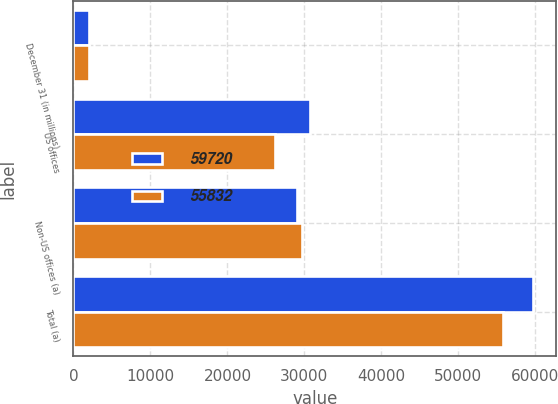Convert chart to OTSL. <chart><loc_0><loc_0><loc_500><loc_500><stacked_bar_chart><ecel><fcel>December 31 (in millions)<fcel>US offices<fcel>Non-US offices (a)<fcel>Total (a)<nl><fcel>59720<fcel>2017<fcel>30671<fcel>29049<fcel>59720<nl><fcel>55832<fcel>2016<fcel>26180<fcel>29652<fcel>55832<nl></chart> 